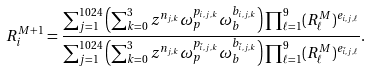<formula> <loc_0><loc_0><loc_500><loc_500>R _ { i } ^ { M + 1 } = \frac { \sum _ { j = 1 } ^ { 1 0 2 4 } \left ( \sum _ { k = 0 } ^ { 3 } z ^ { n _ { j , k } } \omega _ { p } ^ { p _ { i , j , k } } \omega _ { b } ^ { b _ { i , j , k } } \right ) \prod _ { \ell = 1 } ^ { 9 } ( R _ { \ell } ^ { M } ) ^ { e _ { i , j , \ell } } } { \sum _ { j = 1 } ^ { 1 0 2 4 } \left ( \sum _ { k = 0 } ^ { 3 } z ^ { n _ { j , k } } \omega _ { p } ^ { p _ { { \bar { i } } , j , k } } \omega _ { b } ^ { b _ { { \bar { i } } , j , k } } \right ) \prod _ { \ell = 1 } ^ { 9 } ( R _ { \ell } ^ { M } ) ^ { e _ { { \bar { i } } , j , \ell } } } .</formula> 